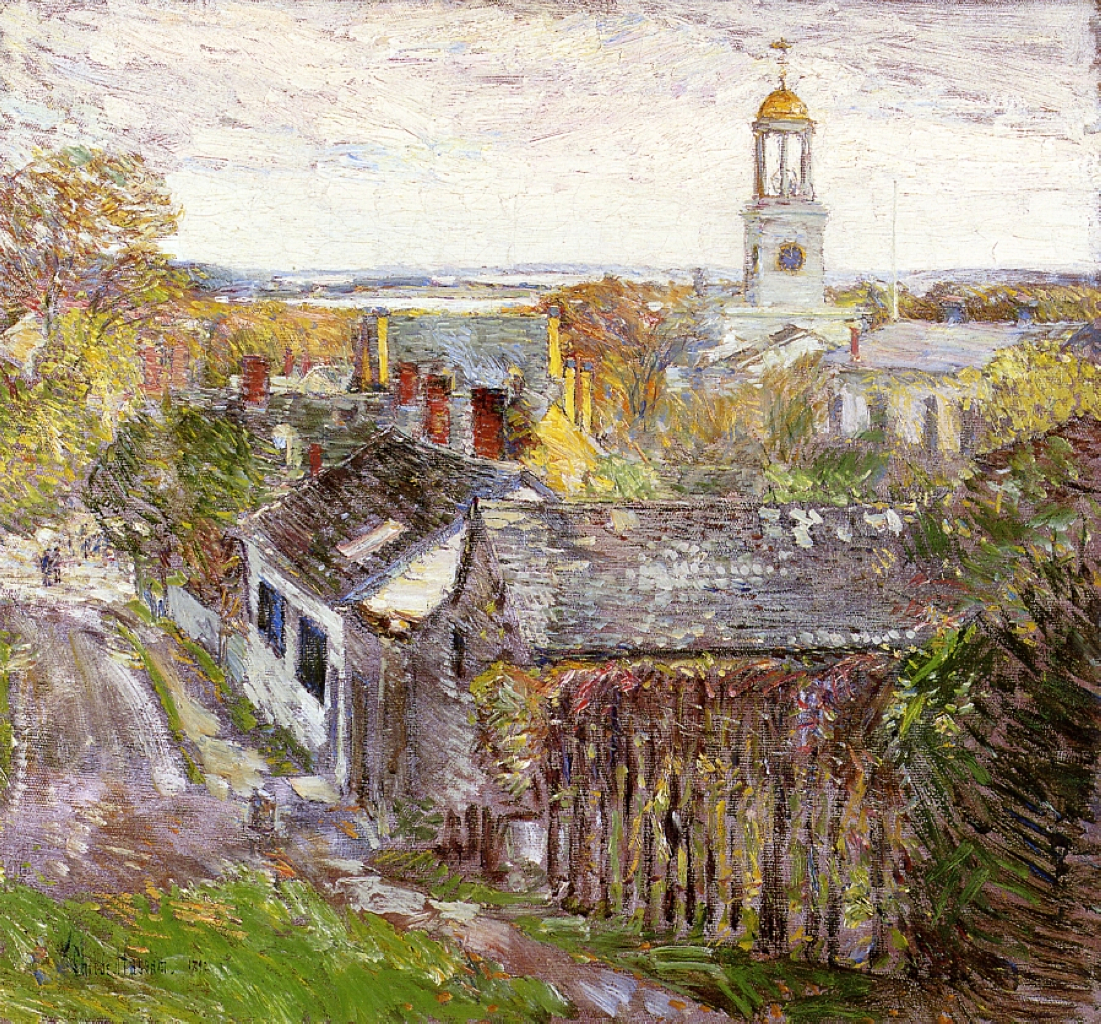Can you describe the architectural features visible in the painting? What do they suggest about the location? The architecture in the painting features modest, cottage-style homes with steeply pitched roofs, which are common in rural or semi-rural settings in Europe, particularly in regions like England or France. The white church with a golden dome, however, is intriguing and suggests a blend of local and possibly Eastern European influences, indicating a unique cultural intersection. The overall rustic and aged look of the structures, along with the use of local materials like brick and wood, suggests a setting that values tradition and may have a rich history. 